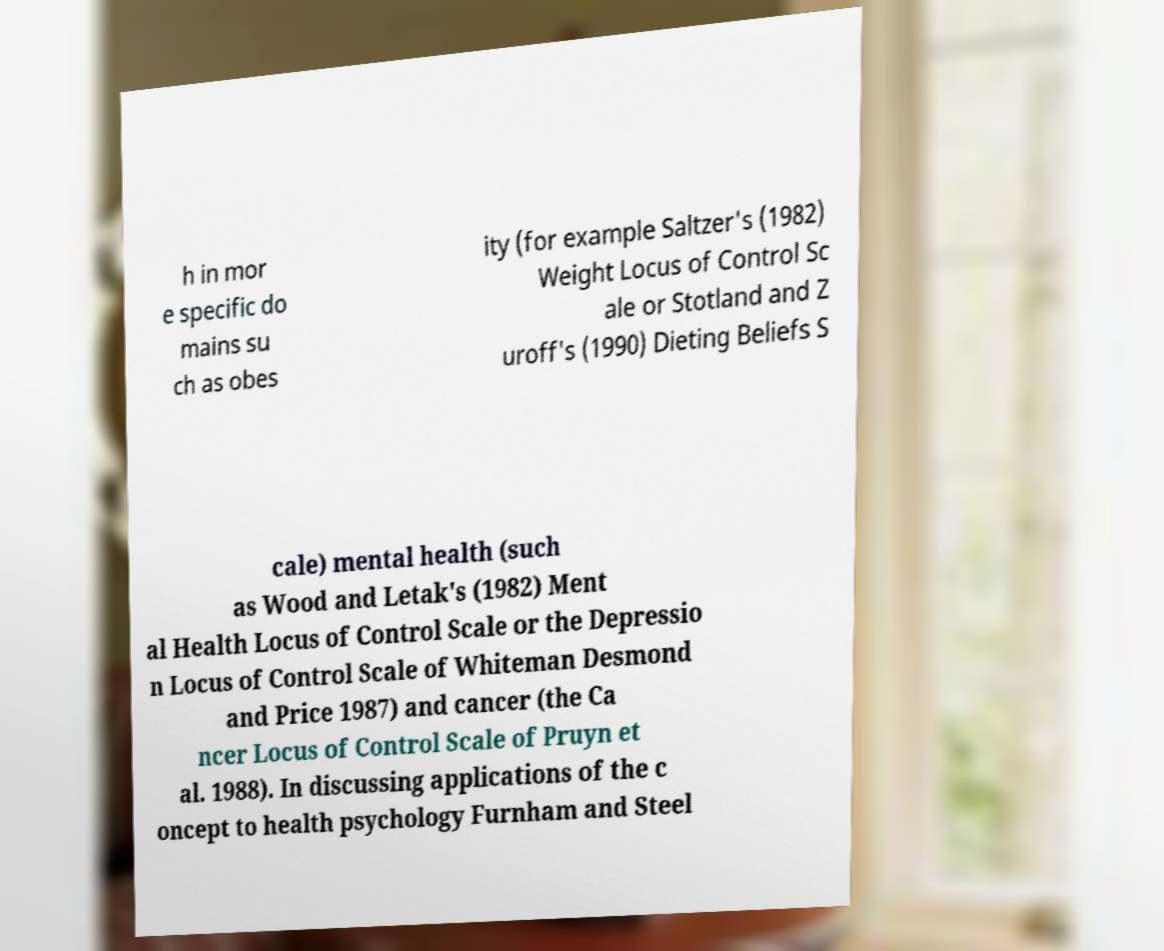Please read and relay the text visible in this image. What does it say? h in mor e specific do mains su ch as obes ity (for example Saltzer's (1982) Weight Locus of Control Sc ale or Stotland and Z uroff's (1990) Dieting Beliefs S cale) mental health (such as Wood and Letak's (1982) Ment al Health Locus of Control Scale or the Depressio n Locus of Control Scale of Whiteman Desmond and Price 1987) and cancer (the Ca ncer Locus of Control Scale of Pruyn et al. 1988). In discussing applications of the c oncept to health psychology Furnham and Steel 